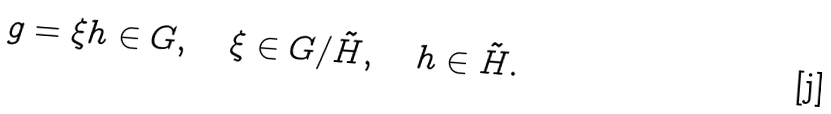Convert formula to latex. <formula><loc_0><loc_0><loc_500><loc_500>g = \xi h \in G , \quad \xi \in G / \tilde { H } , \quad h \in \tilde { H } .</formula> 